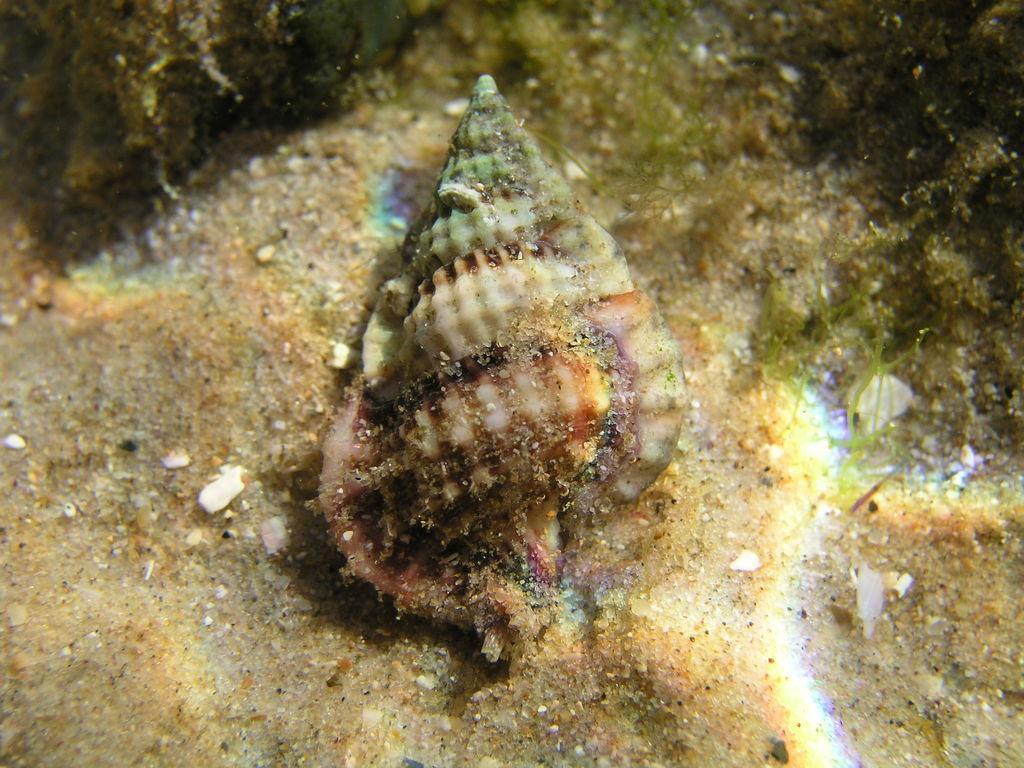Please provide a concise description of this image. In this picture we can see a seashell, there are some stones at the bottom, we can see an underwater environment. 